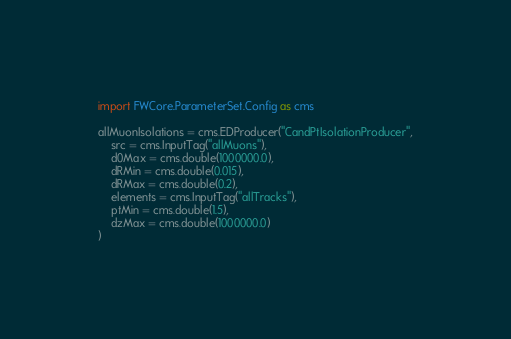<code> <loc_0><loc_0><loc_500><loc_500><_Python_>import FWCore.ParameterSet.Config as cms

allMuonIsolations = cms.EDProducer("CandPtIsolationProducer",
    src = cms.InputTag("allMuons"),
    d0Max = cms.double(1000000.0),
    dRMin = cms.double(0.015),
    dRMax = cms.double(0.2),
    elements = cms.InputTag("allTracks"),
    ptMin = cms.double(1.5),
    dzMax = cms.double(1000000.0)
)


</code> 